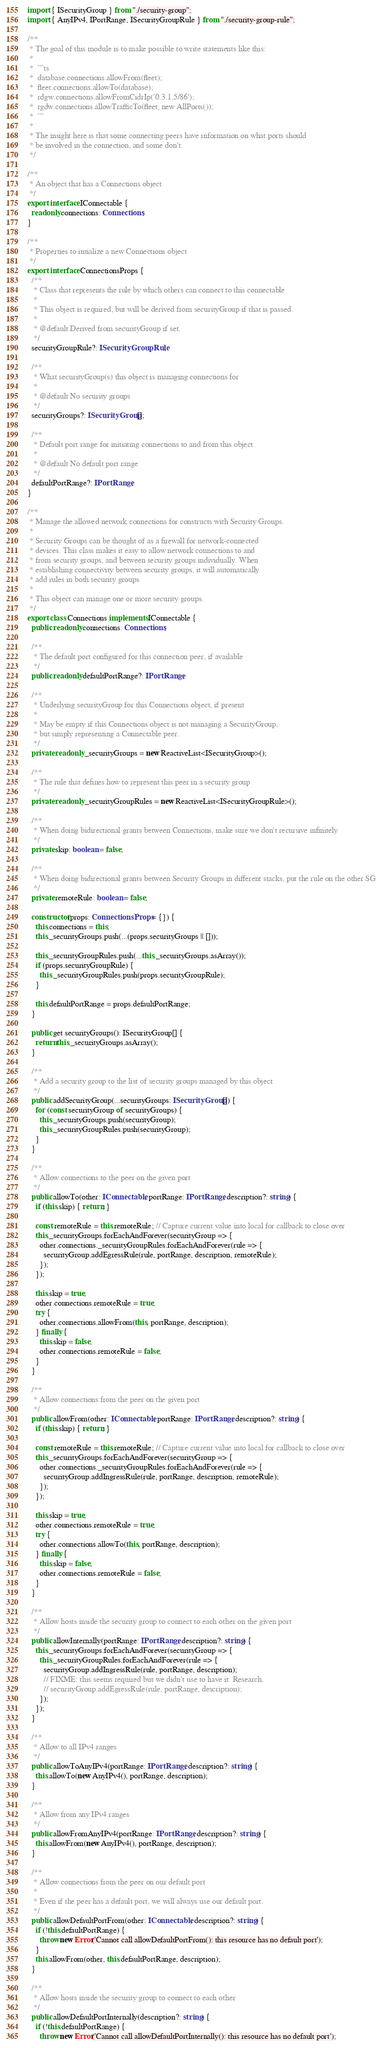<code> <loc_0><loc_0><loc_500><loc_500><_TypeScript_>import { ISecurityGroup } from "./security-group";
import { AnyIPv4, IPortRange, ISecurityGroupRule } from "./security-group-rule";

/**
 * The goal of this module is to make possible to write statements like this:
 *
 *  ```ts
 *  database.connections.allowFrom(fleet);
 *  fleet.connections.allowTo(database);
 *  rdgw.connections.allowFromCidrIp('0.3.1.5/86');
 *  rgdw.connections.allowTrafficTo(fleet, new AllPorts());
 *  ```
 *
 * The insight here is that some connecting peers have information on what ports should
 * be involved in the connection, and some don't.
 */

/**
 * An object that has a Connections object
 */
export interface IConnectable {
  readonly connections: Connections;
}

/**
 * Properties to intialize a new Connections object
 */
export interface ConnectionsProps {
  /**
   * Class that represents the rule by which others can connect to this connectable
   *
   * This object is required, but will be derived from securityGroup if that is passed.
   *
   * @default Derived from securityGroup if set.
   */
  securityGroupRule?: ISecurityGroupRule;

  /**
   * What securityGroup(s) this object is managing connections for
   *
   * @default No security groups
   */
  securityGroups?: ISecurityGroup[];

  /**
   * Default port range for initiating connections to and from this object
   *
   * @default No default port range
   */
  defaultPortRange?: IPortRange;
}

/**
 * Manage the allowed network connections for constructs with Security Groups.
 *
 * Security Groups can be thought of as a firewall for network-connected
 * devices. This class makes it easy to allow network connections to and
 * from security groups, and between security groups individually. When
 * establishing connectivity between security groups, it will automatically
 * add rules in both security groups
 *
 * This object can manage one or more security groups.
 */
export class Connections implements IConnectable {
  public readonly connections: Connections;

  /**
   * The default port configured for this connection peer, if available
   */
  public readonly defaultPortRange?: IPortRange;

  /**
   * Underlying securityGroup for this Connections object, if present
   *
   * May be empty if this Connections object is not managing a SecurityGroup,
   * but simply representing a Connectable peer.
   */
  private readonly _securityGroups = new ReactiveList<ISecurityGroup>();

  /**
   * The rule that defines how to represent this peer in a security group
   */
  private readonly _securityGroupRules = new ReactiveList<ISecurityGroupRule>();

  /**
   * When doing bidirectional grants between Connections, make sure we don't recursive infinitely
   */
  private skip: boolean = false;

  /**
   * When doing bidirectional grants between Security Groups in different stacks, put the rule on the other SG
   */
  private remoteRule: boolean = false;

  constructor(props: ConnectionsProps = {}) {
    this.connections = this;
    this._securityGroups.push(...(props.securityGroups || []));

    this._securityGroupRules.push(...this._securityGroups.asArray());
    if (props.securityGroupRule) {
      this._securityGroupRules.push(props.securityGroupRule);
    }

    this.defaultPortRange = props.defaultPortRange;
  }

  public get securityGroups(): ISecurityGroup[] {
    return this._securityGroups.asArray();
  }

  /**
   * Add a security group to the list of security groups managed by this object
   */
  public addSecurityGroup(...securityGroups: ISecurityGroup[]) {
    for (const securityGroup of securityGroups) {
      this._securityGroups.push(securityGroup);
      this._securityGroupRules.push(securityGroup);
    }
  }

  /**
   * Allow connections to the peer on the given port
   */
  public allowTo(other: IConnectable, portRange: IPortRange, description?: string) {
    if (this.skip) { return; }

    const remoteRule = this.remoteRule; // Capture current value into local for callback to close over
    this._securityGroups.forEachAndForever(securityGroup => {
      other.connections._securityGroupRules.forEachAndForever(rule => {
        securityGroup.addEgressRule(rule, portRange, description, remoteRule);
      });
    });

    this.skip = true;
    other.connections.remoteRule = true;
    try {
      other.connections.allowFrom(this, portRange, description);
    } finally {
      this.skip = false;
      other.connections.remoteRule = false;
    }
  }

  /**
   * Allow connections from the peer on the given port
   */
  public allowFrom(other: IConnectable, portRange: IPortRange, description?: string) {
    if (this.skip) { return; }

    const remoteRule = this.remoteRule; // Capture current value into local for callback to close over
    this._securityGroups.forEachAndForever(securityGroup => {
      other.connections._securityGroupRules.forEachAndForever(rule => {
        securityGroup.addIngressRule(rule, portRange, description, remoteRule);
      });
    });

    this.skip = true;
    other.connections.remoteRule = true;
    try {
      other.connections.allowTo(this, portRange, description);
    } finally {
      this.skip = false;
      other.connections.remoteRule = false;
    }
  }

  /**
   * Allow hosts inside the security group to connect to each other on the given port
   */
  public allowInternally(portRange: IPortRange, description?: string) {
    this._securityGroups.forEachAndForever(securityGroup => {
      this._securityGroupRules.forEachAndForever(rule => {
        securityGroup.addIngressRule(rule, portRange, description);
        // FIXME: this seems required but we didn't use to have it. Research.
        // securityGroup.addEgressRule(rule, portRange, description);
      });
    });
  }

  /**
   * Allow to all IPv4 ranges
   */
  public allowToAnyIPv4(portRange: IPortRange, description?: string) {
    this.allowTo(new AnyIPv4(), portRange, description);
  }

  /**
   * Allow from any IPv4 ranges
   */
  public allowFromAnyIPv4(portRange: IPortRange, description?: string) {
    this.allowFrom(new AnyIPv4(), portRange, description);
  }

  /**
   * Allow connections from the peer on our default port
   *
   * Even if the peer has a default port, we will always use our default port.
   */
  public allowDefaultPortFrom(other: IConnectable, description?: string) {
    if (!this.defaultPortRange) {
      throw new Error('Cannot call allowDefaultPortFrom(): this resource has no default port');
    }
    this.allowFrom(other, this.defaultPortRange, description);
  }

  /**
   * Allow hosts inside the security group to connect to each other
   */
  public allowDefaultPortInternally(description?: string) {
    if (!this.defaultPortRange) {
      throw new Error('Cannot call allowDefaultPortInternally(): this resource has no default port');</code> 